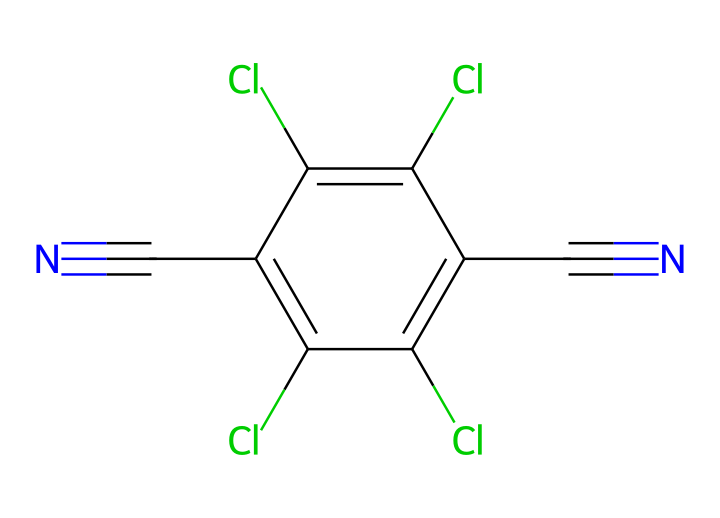What is the molecular formula of chlorothalonil? To determine the molecular formula, you count the various atoms present in the structure. From the SMILES representation, we identify 4 chlorine (Cl) atoms, 2 nitrogen (N) atoms, and 6 carbon (C) atoms, resulting in the formula C6Cl4N2.
Answer: C6Cl4N2 How many aromatic rings does this compound contain? The visual representation shows a single cyclic structure with alternating double bonds indicative of an aromatic ring. There are no additional rings noted in the structure.
Answer: 1 What type of chemical functionality is present in chlorothalonil? The structure shows multiple chlorine substituents, alongside the nitrile groups represented by N#C, indicating that the compound is a chlorinated aromatic nitrile. This is specific to its fungicidal properties.
Answer: chlorinated aromatic nitrile Which element is present in the highest quantity? Counting the various atom types in the structure, we see 4 chlorine atoms, 2 nitrogen atoms, and 6 carbon atoms. Chlorine is the highest in quantity.
Answer: chlorine Why does chlorothalonil qualify as a broad-spectrum fungicide? Its extensive clorinated aromatic structure imparts stability and effectiveness against a wide range of fungal pathogens, which is characteristic of broad-spectrum fungicides. The presence of multiple chlorine atoms enhances its fungicidal efficacy.
Answer: stability and effectiveness What part of the structure denotes its fungicidal properties? The presence of multiple chlorine substituents on the aromatic ring and the nitrile groups is indicative of its fungicidal mechanism, as these parts interact with the target fungi effectively.
Answer: chlorine substituents and nitriles 